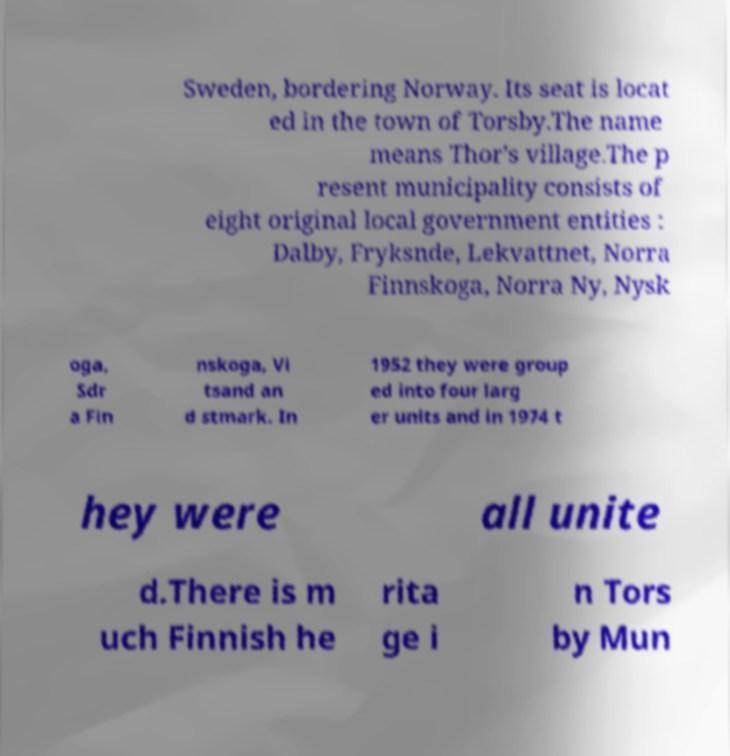Please read and relay the text visible in this image. What does it say? Sweden, bordering Norway. Its seat is locat ed in the town of Torsby.The name means Thor's village.The p resent municipality consists of eight original local government entities : Dalby, Fryksnde, Lekvattnet, Norra Finnskoga, Norra Ny, Nysk oga, Sdr a Fin nskoga, Vi tsand an d stmark. In 1952 they were group ed into four larg er units and in 1974 t hey were all unite d.There is m uch Finnish he rita ge i n Tors by Mun 